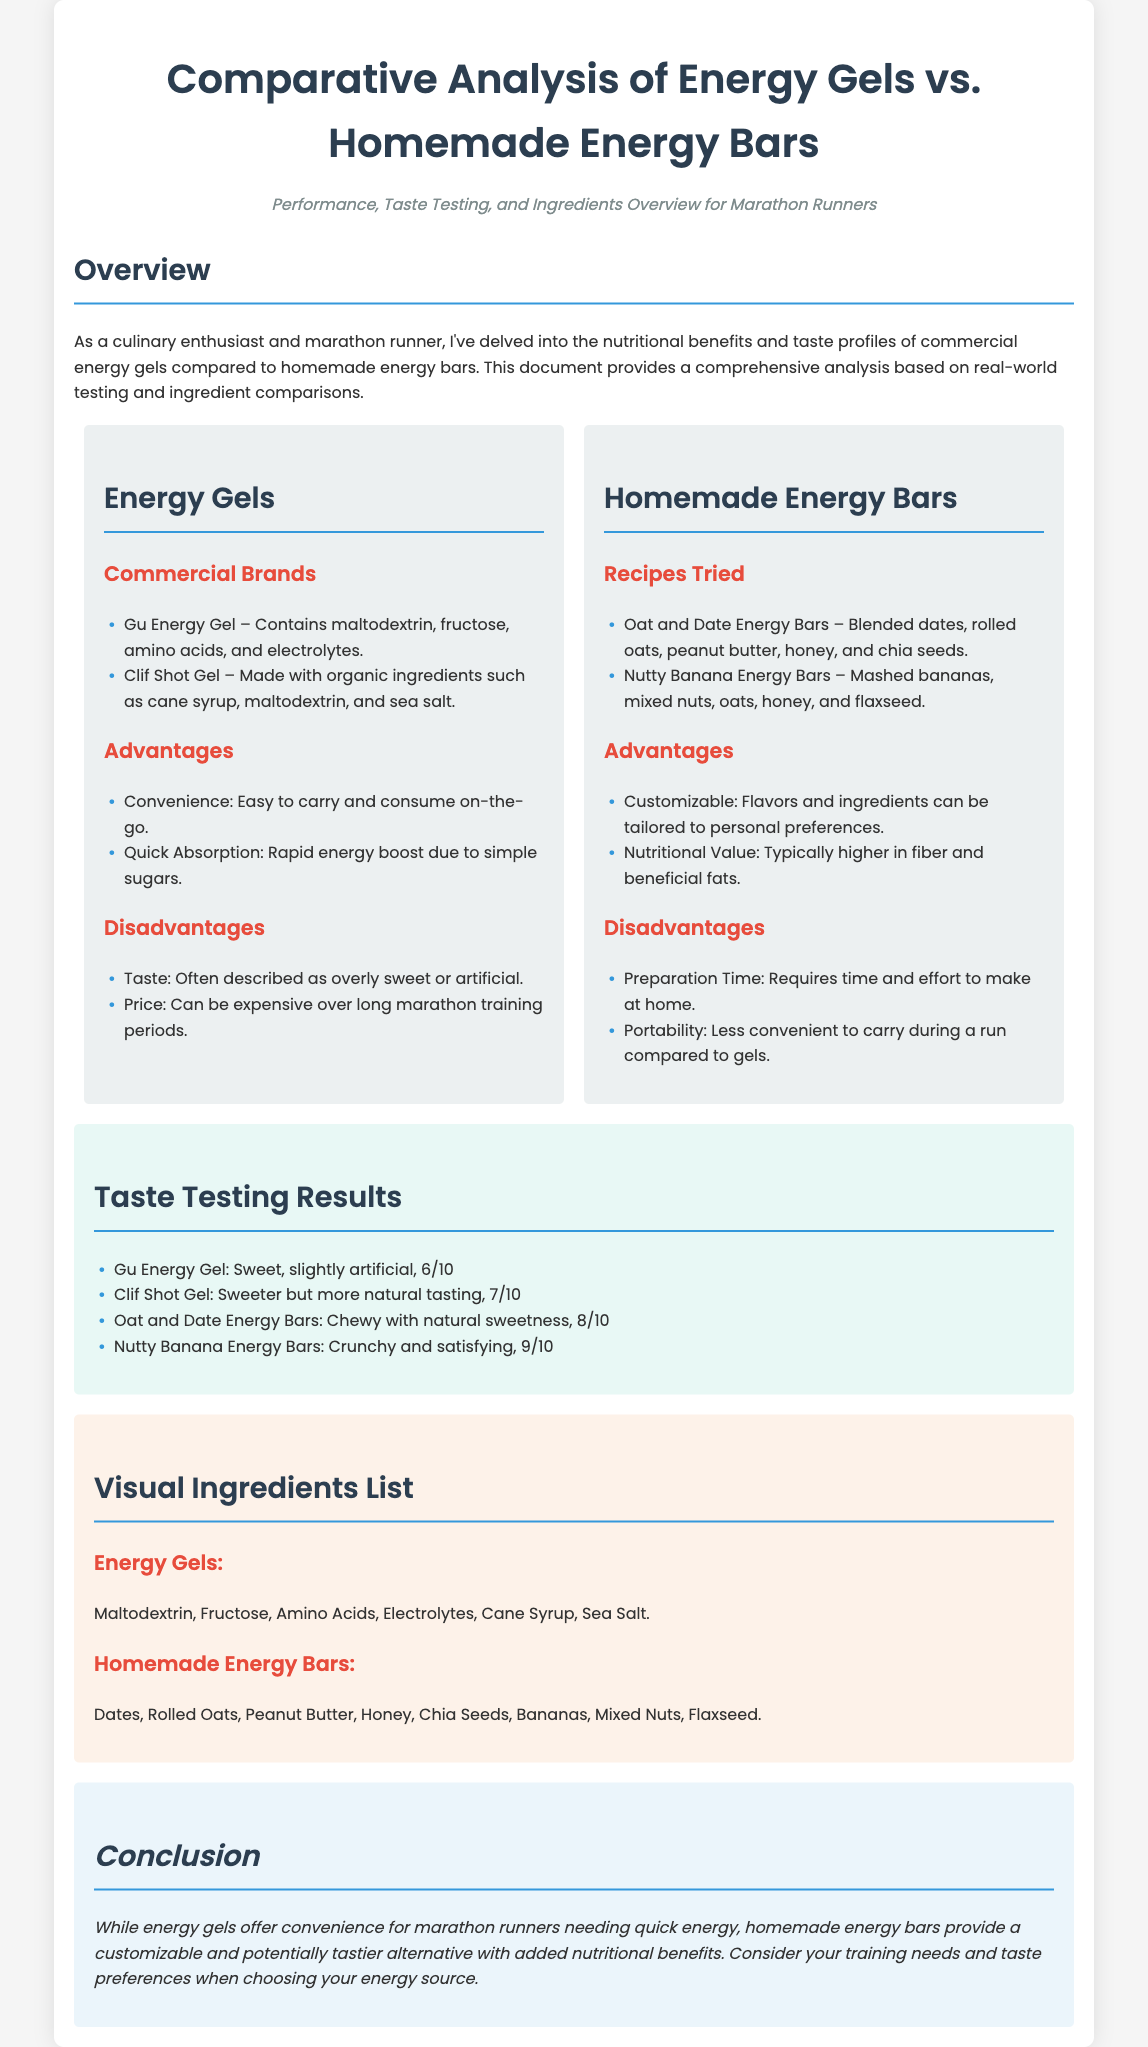What are the two types of energy sources compared? The document compares energy gels and homemade energy bars.
Answer: Energy gels and homemade energy bars What is the taste rating of Nutty Banana Energy Bars? The taste testing results indicate that Nutty Banana Energy Bars received a score of 9 out of 10.
Answer: 9/10 What are the main ingredients of Gu Energy Gel? The ingredients listed for Gu Energy Gel include maltodextrin, fructose, amino acids, and electrolytes.
Answer: Maltodextrin, fructose, amino acids, electrolytes What advantage do homemade energy bars have? One advantage stated for homemade energy bars is that they are customizable to personal preferences.
Answer: Customizable What is a disadvantage of energy gels mentioned? A disadvantage of energy gels noted in the document is that they can taste overly sweet or artificial.
Answer: Overly sweet or artificial What did the Clif Shot Gel taste like according to the results? The taste results describe Clif Shot Gel as sweeter but more natural tasting.
Answer: Sweeter but more natural How many types of homemade energy bars were tested? The document mentions two recipes for homemade energy bars that were tried.
Answer: Two What is one ingredient in Oat and Date Energy Bars? The document lists dates as one of the ingredients in Oat and Date Energy Bars.
Answer: Dates What conclusion is drawn about the convenience of energy gels? The conclusion states that energy gels offer convenience for marathon runners needing quick energy.
Answer: Convenience for quick energy 